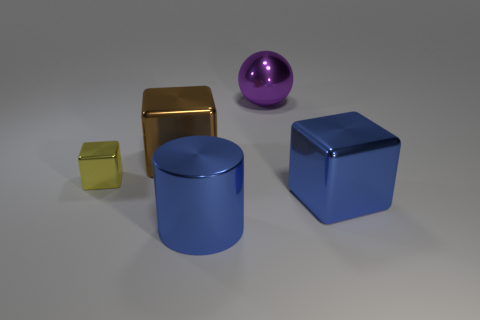Subtract all large blocks. How many blocks are left? 1 Subtract all brown blocks. How many blocks are left? 2 Subtract all cylinders. How many objects are left? 4 Add 3 tiny yellow metal cubes. How many objects exist? 8 Subtract all green balls. How many gray cylinders are left? 0 Subtract 1 cubes. How many cubes are left? 2 Subtract all cyan balls. Subtract all purple cylinders. How many balls are left? 1 Subtract all cyan metal cylinders. Subtract all large blue shiny cylinders. How many objects are left? 4 Add 1 spheres. How many spheres are left? 2 Add 1 small cyan shiny objects. How many small cyan shiny objects exist? 1 